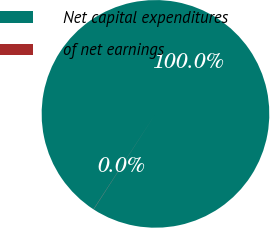<chart> <loc_0><loc_0><loc_500><loc_500><pie_chart><fcel>Net capital expenditures<fcel>of net earnings<nl><fcel>99.98%<fcel>0.02%<nl></chart> 